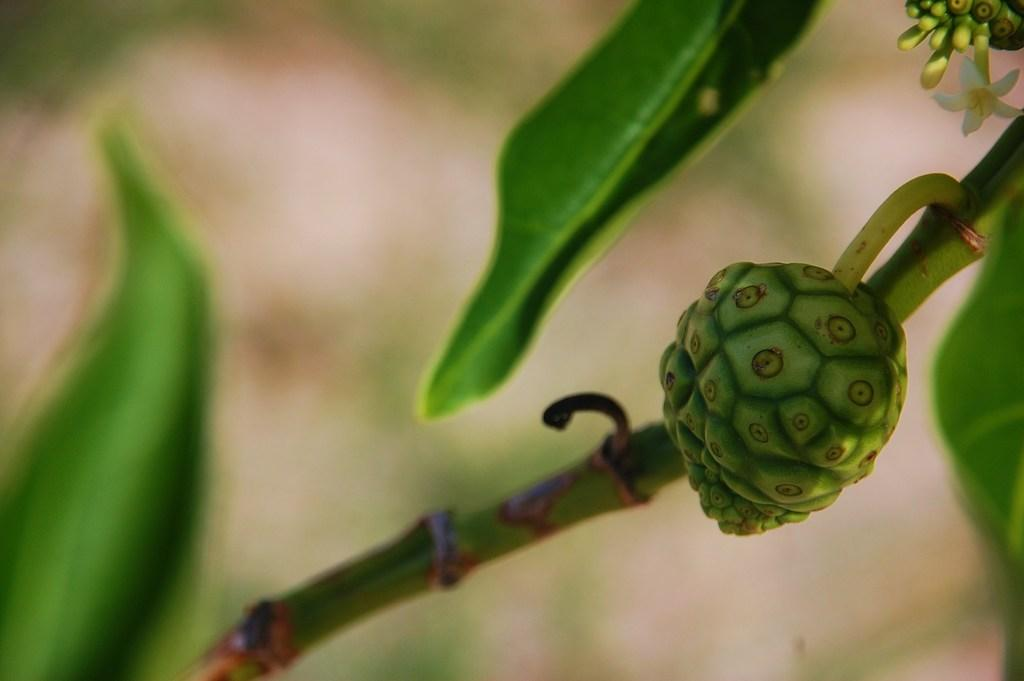What is located in the center of the image? There is a plant, a fruit, and a flower in the center of the image. Can you describe the flower in the center of the image? The flower in the center of the image is in white color. How does the plant turn into a fiction novel in the image? The plant does not turn into a fiction novel in the image; it remains a plant. Is there a sink visible in the image? There is no sink present in the image. 